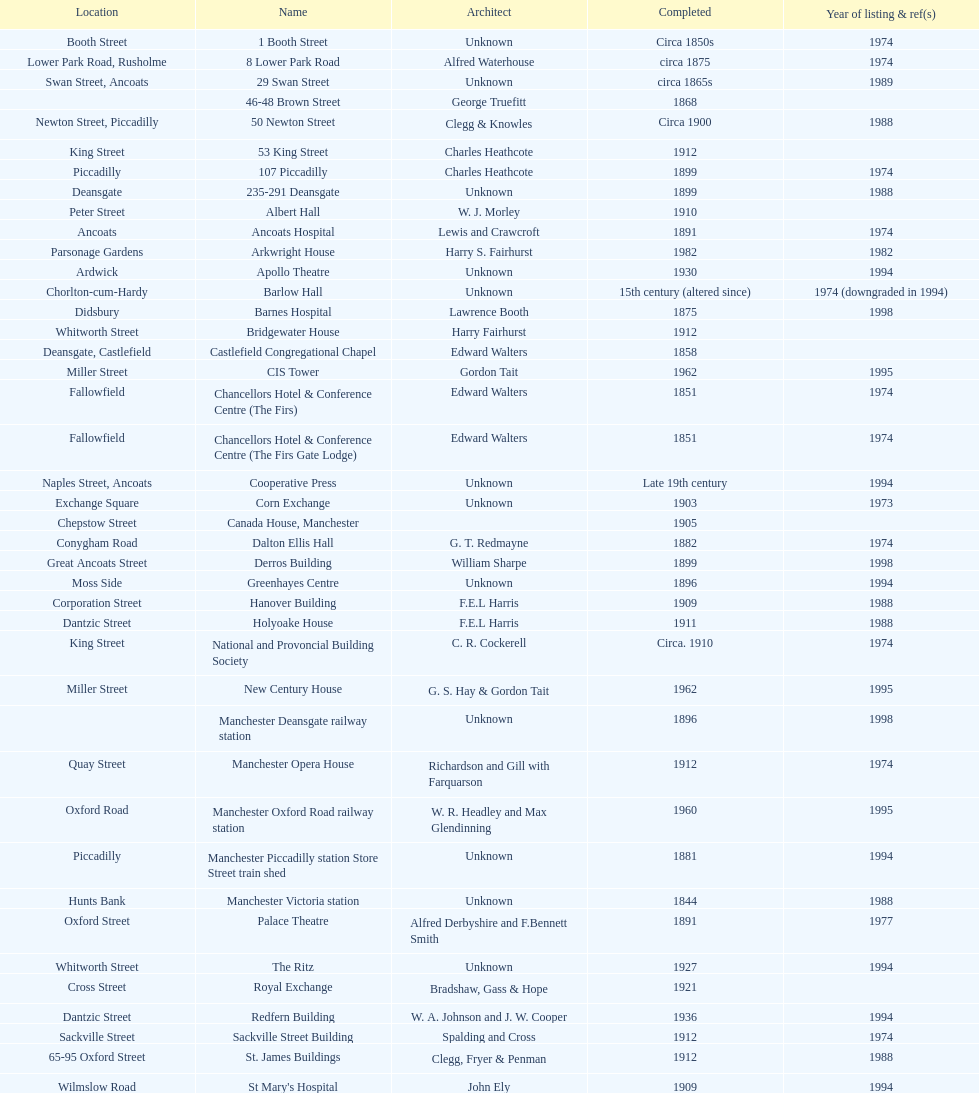Which two buildings were listed before 1974? The Old Wellington Inn, Smithfield Market Hall. 